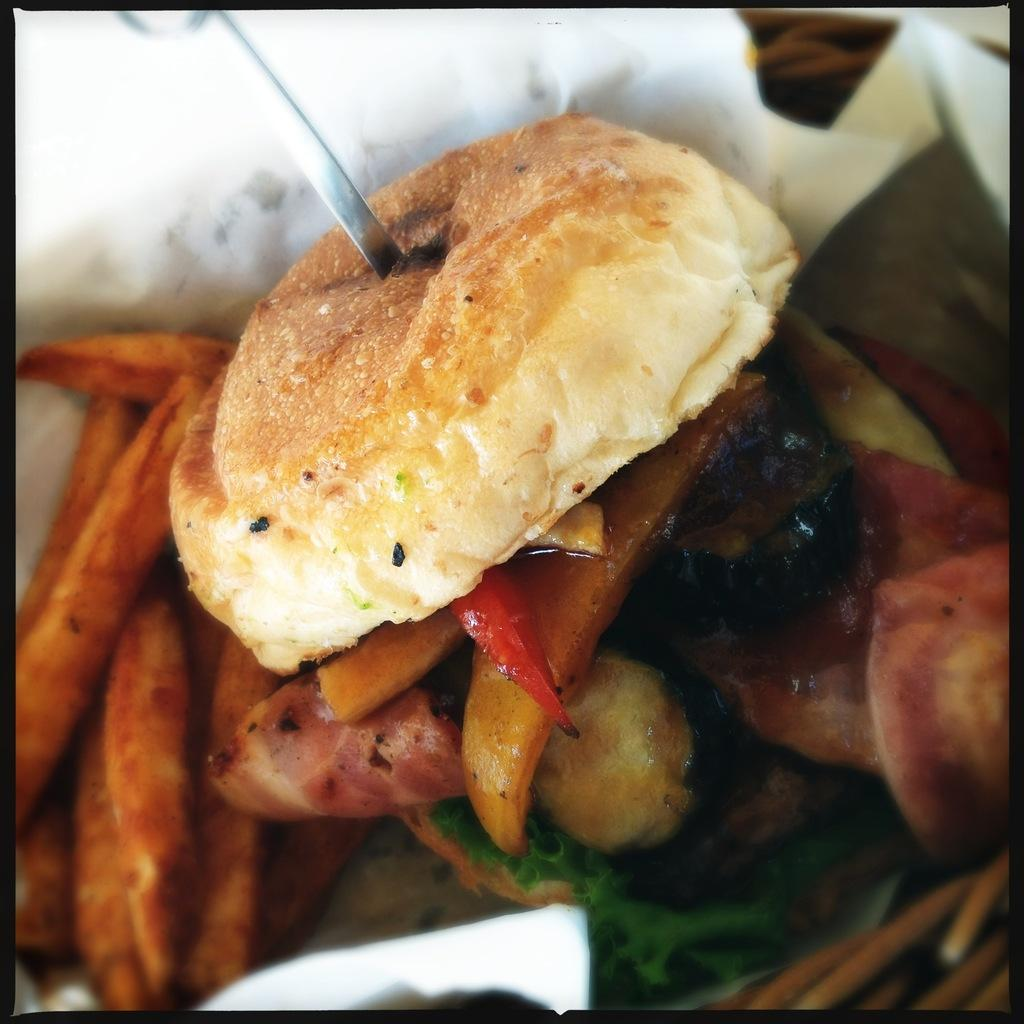What is present in the image related to food? There is food in the image. What utensil can be seen in the image? There is a knife in the image. What else is on the surface in the image besides the food and knife? There are other objects on the surface in the image. How many icicles are hanging from the ceiling in the image? There are no icicles present in the image. What type of bears can be seen interacting with the food in the image? There are no bears present in the image. 